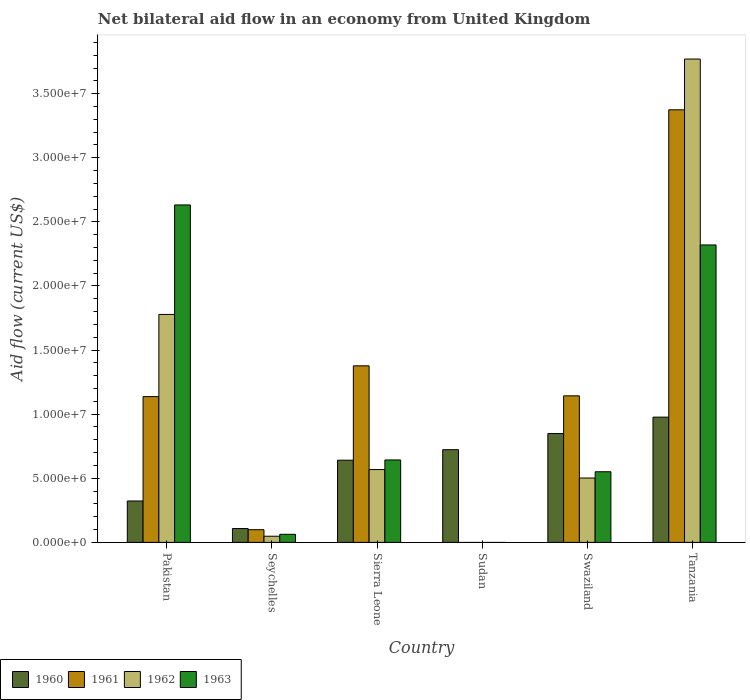How many bars are there on the 3rd tick from the left?
Make the answer very short. 4. How many bars are there on the 2nd tick from the right?
Your answer should be compact. 4. What is the label of the 2nd group of bars from the left?
Provide a succinct answer. Seychelles. Across all countries, what is the maximum net bilateral aid flow in 1962?
Your answer should be very brief. 3.77e+07. Across all countries, what is the minimum net bilateral aid flow in 1960?
Your answer should be very brief. 1.08e+06. What is the total net bilateral aid flow in 1962 in the graph?
Your response must be concise. 6.67e+07. What is the difference between the net bilateral aid flow in 1962 in Swaziland and that in Tanzania?
Ensure brevity in your answer.  -3.27e+07. What is the difference between the net bilateral aid flow in 1961 in Seychelles and the net bilateral aid flow in 1962 in Tanzania?
Give a very brief answer. -3.67e+07. What is the average net bilateral aid flow in 1960 per country?
Make the answer very short. 6.04e+06. What is the difference between the net bilateral aid flow of/in 1960 and net bilateral aid flow of/in 1961 in Tanzania?
Give a very brief answer. -2.40e+07. What is the ratio of the net bilateral aid flow in 1960 in Pakistan to that in Seychelles?
Provide a short and direct response. 2.99. Is the net bilateral aid flow in 1961 in Sierra Leone less than that in Tanzania?
Provide a succinct answer. Yes. What is the difference between the highest and the second highest net bilateral aid flow in 1963?
Make the answer very short. 3.12e+06. What is the difference between the highest and the lowest net bilateral aid flow in 1960?
Your answer should be very brief. 8.69e+06. In how many countries, is the net bilateral aid flow in 1960 greater than the average net bilateral aid flow in 1960 taken over all countries?
Your response must be concise. 4. Is the sum of the net bilateral aid flow in 1960 in Swaziland and Tanzania greater than the maximum net bilateral aid flow in 1963 across all countries?
Give a very brief answer. No. Is it the case that in every country, the sum of the net bilateral aid flow in 1962 and net bilateral aid flow in 1960 is greater than the sum of net bilateral aid flow in 1961 and net bilateral aid flow in 1963?
Offer a terse response. No. Is it the case that in every country, the sum of the net bilateral aid flow in 1961 and net bilateral aid flow in 1962 is greater than the net bilateral aid flow in 1963?
Offer a terse response. No. How many countries are there in the graph?
Your answer should be very brief. 6. What is the difference between two consecutive major ticks on the Y-axis?
Your answer should be compact. 5.00e+06. How many legend labels are there?
Your answer should be compact. 4. What is the title of the graph?
Keep it short and to the point. Net bilateral aid flow in an economy from United Kingdom. What is the Aid flow (current US$) of 1960 in Pakistan?
Your answer should be very brief. 3.23e+06. What is the Aid flow (current US$) in 1961 in Pakistan?
Make the answer very short. 1.14e+07. What is the Aid flow (current US$) of 1962 in Pakistan?
Provide a succinct answer. 1.78e+07. What is the Aid flow (current US$) of 1963 in Pakistan?
Make the answer very short. 2.63e+07. What is the Aid flow (current US$) of 1960 in Seychelles?
Provide a succinct answer. 1.08e+06. What is the Aid flow (current US$) in 1961 in Seychelles?
Give a very brief answer. 9.90e+05. What is the Aid flow (current US$) in 1963 in Seychelles?
Ensure brevity in your answer.  6.30e+05. What is the Aid flow (current US$) in 1960 in Sierra Leone?
Keep it short and to the point. 6.41e+06. What is the Aid flow (current US$) of 1961 in Sierra Leone?
Offer a terse response. 1.38e+07. What is the Aid flow (current US$) in 1962 in Sierra Leone?
Offer a very short reply. 5.68e+06. What is the Aid flow (current US$) of 1963 in Sierra Leone?
Your answer should be compact. 6.43e+06. What is the Aid flow (current US$) in 1960 in Sudan?
Your answer should be compact. 7.23e+06. What is the Aid flow (current US$) in 1961 in Sudan?
Your answer should be compact. 0. What is the Aid flow (current US$) of 1962 in Sudan?
Offer a terse response. 0. What is the Aid flow (current US$) of 1963 in Sudan?
Offer a very short reply. 0. What is the Aid flow (current US$) in 1960 in Swaziland?
Your answer should be compact. 8.49e+06. What is the Aid flow (current US$) in 1961 in Swaziland?
Your response must be concise. 1.14e+07. What is the Aid flow (current US$) of 1962 in Swaziland?
Your response must be concise. 5.02e+06. What is the Aid flow (current US$) of 1963 in Swaziland?
Ensure brevity in your answer.  5.51e+06. What is the Aid flow (current US$) of 1960 in Tanzania?
Provide a succinct answer. 9.77e+06. What is the Aid flow (current US$) of 1961 in Tanzania?
Offer a very short reply. 3.37e+07. What is the Aid flow (current US$) of 1962 in Tanzania?
Your answer should be very brief. 3.77e+07. What is the Aid flow (current US$) in 1963 in Tanzania?
Your answer should be very brief. 2.32e+07. Across all countries, what is the maximum Aid flow (current US$) of 1960?
Give a very brief answer. 9.77e+06. Across all countries, what is the maximum Aid flow (current US$) of 1961?
Provide a succinct answer. 3.37e+07. Across all countries, what is the maximum Aid flow (current US$) of 1962?
Keep it short and to the point. 3.77e+07. Across all countries, what is the maximum Aid flow (current US$) in 1963?
Offer a terse response. 2.63e+07. Across all countries, what is the minimum Aid flow (current US$) of 1960?
Keep it short and to the point. 1.08e+06. Across all countries, what is the minimum Aid flow (current US$) in 1962?
Offer a terse response. 0. What is the total Aid flow (current US$) in 1960 in the graph?
Provide a short and direct response. 3.62e+07. What is the total Aid flow (current US$) in 1961 in the graph?
Offer a terse response. 7.13e+07. What is the total Aid flow (current US$) of 1962 in the graph?
Your response must be concise. 6.67e+07. What is the total Aid flow (current US$) in 1963 in the graph?
Your answer should be compact. 6.21e+07. What is the difference between the Aid flow (current US$) of 1960 in Pakistan and that in Seychelles?
Offer a very short reply. 2.15e+06. What is the difference between the Aid flow (current US$) in 1961 in Pakistan and that in Seychelles?
Keep it short and to the point. 1.04e+07. What is the difference between the Aid flow (current US$) of 1962 in Pakistan and that in Seychelles?
Make the answer very short. 1.73e+07. What is the difference between the Aid flow (current US$) in 1963 in Pakistan and that in Seychelles?
Offer a terse response. 2.57e+07. What is the difference between the Aid flow (current US$) of 1960 in Pakistan and that in Sierra Leone?
Give a very brief answer. -3.18e+06. What is the difference between the Aid flow (current US$) of 1961 in Pakistan and that in Sierra Leone?
Provide a short and direct response. -2.40e+06. What is the difference between the Aid flow (current US$) of 1962 in Pakistan and that in Sierra Leone?
Offer a terse response. 1.21e+07. What is the difference between the Aid flow (current US$) in 1963 in Pakistan and that in Sierra Leone?
Your response must be concise. 1.99e+07. What is the difference between the Aid flow (current US$) of 1960 in Pakistan and that in Swaziland?
Your response must be concise. -5.26e+06. What is the difference between the Aid flow (current US$) in 1961 in Pakistan and that in Swaziland?
Ensure brevity in your answer.  -6.00e+04. What is the difference between the Aid flow (current US$) of 1962 in Pakistan and that in Swaziland?
Make the answer very short. 1.28e+07. What is the difference between the Aid flow (current US$) of 1963 in Pakistan and that in Swaziland?
Ensure brevity in your answer.  2.08e+07. What is the difference between the Aid flow (current US$) in 1960 in Pakistan and that in Tanzania?
Provide a succinct answer. -6.54e+06. What is the difference between the Aid flow (current US$) in 1961 in Pakistan and that in Tanzania?
Give a very brief answer. -2.24e+07. What is the difference between the Aid flow (current US$) of 1962 in Pakistan and that in Tanzania?
Give a very brief answer. -1.99e+07. What is the difference between the Aid flow (current US$) of 1963 in Pakistan and that in Tanzania?
Offer a terse response. 3.12e+06. What is the difference between the Aid flow (current US$) in 1960 in Seychelles and that in Sierra Leone?
Your response must be concise. -5.33e+06. What is the difference between the Aid flow (current US$) in 1961 in Seychelles and that in Sierra Leone?
Offer a terse response. -1.28e+07. What is the difference between the Aid flow (current US$) in 1962 in Seychelles and that in Sierra Leone?
Provide a succinct answer. -5.20e+06. What is the difference between the Aid flow (current US$) of 1963 in Seychelles and that in Sierra Leone?
Your answer should be compact. -5.80e+06. What is the difference between the Aid flow (current US$) of 1960 in Seychelles and that in Sudan?
Give a very brief answer. -6.15e+06. What is the difference between the Aid flow (current US$) in 1960 in Seychelles and that in Swaziland?
Provide a succinct answer. -7.41e+06. What is the difference between the Aid flow (current US$) of 1961 in Seychelles and that in Swaziland?
Your answer should be very brief. -1.04e+07. What is the difference between the Aid flow (current US$) in 1962 in Seychelles and that in Swaziland?
Keep it short and to the point. -4.54e+06. What is the difference between the Aid flow (current US$) in 1963 in Seychelles and that in Swaziland?
Offer a very short reply. -4.88e+06. What is the difference between the Aid flow (current US$) in 1960 in Seychelles and that in Tanzania?
Offer a terse response. -8.69e+06. What is the difference between the Aid flow (current US$) of 1961 in Seychelles and that in Tanzania?
Offer a terse response. -3.28e+07. What is the difference between the Aid flow (current US$) of 1962 in Seychelles and that in Tanzania?
Your answer should be very brief. -3.72e+07. What is the difference between the Aid flow (current US$) of 1963 in Seychelles and that in Tanzania?
Ensure brevity in your answer.  -2.26e+07. What is the difference between the Aid flow (current US$) of 1960 in Sierra Leone and that in Sudan?
Ensure brevity in your answer.  -8.20e+05. What is the difference between the Aid flow (current US$) of 1960 in Sierra Leone and that in Swaziland?
Give a very brief answer. -2.08e+06. What is the difference between the Aid flow (current US$) in 1961 in Sierra Leone and that in Swaziland?
Your answer should be very brief. 2.34e+06. What is the difference between the Aid flow (current US$) of 1962 in Sierra Leone and that in Swaziland?
Keep it short and to the point. 6.60e+05. What is the difference between the Aid flow (current US$) of 1963 in Sierra Leone and that in Swaziland?
Offer a terse response. 9.20e+05. What is the difference between the Aid flow (current US$) of 1960 in Sierra Leone and that in Tanzania?
Make the answer very short. -3.36e+06. What is the difference between the Aid flow (current US$) in 1961 in Sierra Leone and that in Tanzania?
Offer a very short reply. -2.00e+07. What is the difference between the Aid flow (current US$) of 1962 in Sierra Leone and that in Tanzania?
Give a very brief answer. -3.20e+07. What is the difference between the Aid flow (current US$) in 1963 in Sierra Leone and that in Tanzania?
Offer a very short reply. -1.68e+07. What is the difference between the Aid flow (current US$) in 1960 in Sudan and that in Swaziland?
Ensure brevity in your answer.  -1.26e+06. What is the difference between the Aid flow (current US$) in 1960 in Sudan and that in Tanzania?
Offer a very short reply. -2.54e+06. What is the difference between the Aid flow (current US$) in 1960 in Swaziland and that in Tanzania?
Your answer should be very brief. -1.28e+06. What is the difference between the Aid flow (current US$) of 1961 in Swaziland and that in Tanzania?
Ensure brevity in your answer.  -2.23e+07. What is the difference between the Aid flow (current US$) in 1962 in Swaziland and that in Tanzania?
Provide a short and direct response. -3.27e+07. What is the difference between the Aid flow (current US$) in 1963 in Swaziland and that in Tanzania?
Make the answer very short. -1.77e+07. What is the difference between the Aid flow (current US$) of 1960 in Pakistan and the Aid flow (current US$) of 1961 in Seychelles?
Your answer should be very brief. 2.24e+06. What is the difference between the Aid flow (current US$) of 1960 in Pakistan and the Aid flow (current US$) of 1962 in Seychelles?
Keep it short and to the point. 2.75e+06. What is the difference between the Aid flow (current US$) of 1960 in Pakistan and the Aid flow (current US$) of 1963 in Seychelles?
Keep it short and to the point. 2.60e+06. What is the difference between the Aid flow (current US$) in 1961 in Pakistan and the Aid flow (current US$) in 1962 in Seychelles?
Keep it short and to the point. 1.09e+07. What is the difference between the Aid flow (current US$) in 1961 in Pakistan and the Aid flow (current US$) in 1963 in Seychelles?
Provide a short and direct response. 1.07e+07. What is the difference between the Aid flow (current US$) of 1962 in Pakistan and the Aid flow (current US$) of 1963 in Seychelles?
Give a very brief answer. 1.72e+07. What is the difference between the Aid flow (current US$) of 1960 in Pakistan and the Aid flow (current US$) of 1961 in Sierra Leone?
Offer a terse response. -1.05e+07. What is the difference between the Aid flow (current US$) of 1960 in Pakistan and the Aid flow (current US$) of 1962 in Sierra Leone?
Make the answer very short. -2.45e+06. What is the difference between the Aid flow (current US$) of 1960 in Pakistan and the Aid flow (current US$) of 1963 in Sierra Leone?
Make the answer very short. -3.20e+06. What is the difference between the Aid flow (current US$) in 1961 in Pakistan and the Aid flow (current US$) in 1962 in Sierra Leone?
Give a very brief answer. 5.69e+06. What is the difference between the Aid flow (current US$) in 1961 in Pakistan and the Aid flow (current US$) in 1963 in Sierra Leone?
Keep it short and to the point. 4.94e+06. What is the difference between the Aid flow (current US$) of 1962 in Pakistan and the Aid flow (current US$) of 1963 in Sierra Leone?
Ensure brevity in your answer.  1.14e+07. What is the difference between the Aid flow (current US$) of 1960 in Pakistan and the Aid flow (current US$) of 1961 in Swaziland?
Offer a very short reply. -8.20e+06. What is the difference between the Aid flow (current US$) of 1960 in Pakistan and the Aid flow (current US$) of 1962 in Swaziland?
Your response must be concise. -1.79e+06. What is the difference between the Aid flow (current US$) of 1960 in Pakistan and the Aid flow (current US$) of 1963 in Swaziland?
Give a very brief answer. -2.28e+06. What is the difference between the Aid flow (current US$) of 1961 in Pakistan and the Aid flow (current US$) of 1962 in Swaziland?
Keep it short and to the point. 6.35e+06. What is the difference between the Aid flow (current US$) of 1961 in Pakistan and the Aid flow (current US$) of 1963 in Swaziland?
Your answer should be very brief. 5.86e+06. What is the difference between the Aid flow (current US$) of 1962 in Pakistan and the Aid flow (current US$) of 1963 in Swaziland?
Make the answer very short. 1.23e+07. What is the difference between the Aid flow (current US$) in 1960 in Pakistan and the Aid flow (current US$) in 1961 in Tanzania?
Provide a succinct answer. -3.05e+07. What is the difference between the Aid flow (current US$) of 1960 in Pakistan and the Aid flow (current US$) of 1962 in Tanzania?
Give a very brief answer. -3.45e+07. What is the difference between the Aid flow (current US$) of 1960 in Pakistan and the Aid flow (current US$) of 1963 in Tanzania?
Ensure brevity in your answer.  -2.00e+07. What is the difference between the Aid flow (current US$) in 1961 in Pakistan and the Aid flow (current US$) in 1962 in Tanzania?
Offer a very short reply. -2.63e+07. What is the difference between the Aid flow (current US$) of 1961 in Pakistan and the Aid flow (current US$) of 1963 in Tanzania?
Your answer should be very brief. -1.18e+07. What is the difference between the Aid flow (current US$) in 1962 in Pakistan and the Aid flow (current US$) in 1963 in Tanzania?
Provide a succinct answer. -5.42e+06. What is the difference between the Aid flow (current US$) in 1960 in Seychelles and the Aid flow (current US$) in 1961 in Sierra Leone?
Your answer should be very brief. -1.27e+07. What is the difference between the Aid flow (current US$) of 1960 in Seychelles and the Aid flow (current US$) of 1962 in Sierra Leone?
Your answer should be compact. -4.60e+06. What is the difference between the Aid flow (current US$) in 1960 in Seychelles and the Aid flow (current US$) in 1963 in Sierra Leone?
Give a very brief answer. -5.35e+06. What is the difference between the Aid flow (current US$) in 1961 in Seychelles and the Aid flow (current US$) in 1962 in Sierra Leone?
Ensure brevity in your answer.  -4.69e+06. What is the difference between the Aid flow (current US$) in 1961 in Seychelles and the Aid flow (current US$) in 1963 in Sierra Leone?
Provide a succinct answer. -5.44e+06. What is the difference between the Aid flow (current US$) in 1962 in Seychelles and the Aid flow (current US$) in 1963 in Sierra Leone?
Your answer should be very brief. -5.95e+06. What is the difference between the Aid flow (current US$) of 1960 in Seychelles and the Aid flow (current US$) of 1961 in Swaziland?
Offer a very short reply. -1.04e+07. What is the difference between the Aid flow (current US$) in 1960 in Seychelles and the Aid flow (current US$) in 1962 in Swaziland?
Your answer should be compact. -3.94e+06. What is the difference between the Aid flow (current US$) in 1960 in Seychelles and the Aid flow (current US$) in 1963 in Swaziland?
Your answer should be very brief. -4.43e+06. What is the difference between the Aid flow (current US$) of 1961 in Seychelles and the Aid flow (current US$) of 1962 in Swaziland?
Your answer should be compact. -4.03e+06. What is the difference between the Aid flow (current US$) in 1961 in Seychelles and the Aid flow (current US$) in 1963 in Swaziland?
Offer a terse response. -4.52e+06. What is the difference between the Aid flow (current US$) of 1962 in Seychelles and the Aid flow (current US$) of 1963 in Swaziland?
Ensure brevity in your answer.  -5.03e+06. What is the difference between the Aid flow (current US$) of 1960 in Seychelles and the Aid flow (current US$) of 1961 in Tanzania?
Your answer should be very brief. -3.27e+07. What is the difference between the Aid flow (current US$) of 1960 in Seychelles and the Aid flow (current US$) of 1962 in Tanzania?
Make the answer very short. -3.66e+07. What is the difference between the Aid flow (current US$) in 1960 in Seychelles and the Aid flow (current US$) in 1963 in Tanzania?
Your answer should be very brief. -2.21e+07. What is the difference between the Aid flow (current US$) of 1961 in Seychelles and the Aid flow (current US$) of 1962 in Tanzania?
Provide a succinct answer. -3.67e+07. What is the difference between the Aid flow (current US$) of 1961 in Seychelles and the Aid flow (current US$) of 1963 in Tanzania?
Keep it short and to the point. -2.22e+07. What is the difference between the Aid flow (current US$) of 1962 in Seychelles and the Aid flow (current US$) of 1963 in Tanzania?
Your answer should be very brief. -2.27e+07. What is the difference between the Aid flow (current US$) of 1960 in Sierra Leone and the Aid flow (current US$) of 1961 in Swaziland?
Offer a terse response. -5.02e+06. What is the difference between the Aid flow (current US$) of 1960 in Sierra Leone and the Aid flow (current US$) of 1962 in Swaziland?
Your answer should be very brief. 1.39e+06. What is the difference between the Aid flow (current US$) in 1961 in Sierra Leone and the Aid flow (current US$) in 1962 in Swaziland?
Your answer should be compact. 8.75e+06. What is the difference between the Aid flow (current US$) in 1961 in Sierra Leone and the Aid flow (current US$) in 1963 in Swaziland?
Keep it short and to the point. 8.26e+06. What is the difference between the Aid flow (current US$) of 1960 in Sierra Leone and the Aid flow (current US$) of 1961 in Tanzania?
Provide a short and direct response. -2.73e+07. What is the difference between the Aid flow (current US$) of 1960 in Sierra Leone and the Aid flow (current US$) of 1962 in Tanzania?
Provide a short and direct response. -3.13e+07. What is the difference between the Aid flow (current US$) in 1960 in Sierra Leone and the Aid flow (current US$) in 1963 in Tanzania?
Your answer should be compact. -1.68e+07. What is the difference between the Aid flow (current US$) in 1961 in Sierra Leone and the Aid flow (current US$) in 1962 in Tanzania?
Ensure brevity in your answer.  -2.39e+07. What is the difference between the Aid flow (current US$) of 1961 in Sierra Leone and the Aid flow (current US$) of 1963 in Tanzania?
Offer a terse response. -9.43e+06. What is the difference between the Aid flow (current US$) of 1962 in Sierra Leone and the Aid flow (current US$) of 1963 in Tanzania?
Your response must be concise. -1.75e+07. What is the difference between the Aid flow (current US$) in 1960 in Sudan and the Aid flow (current US$) in 1961 in Swaziland?
Provide a succinct answer. -4.20e+06. What is the difference between the Aid flow (current US$) in 1960 in Sudan and the Aid flow (current US$) in 1962 in Swaziland?
Ensure brevity in your answer.  2.21e+06. What is the difference between the Aid flow (current US$) in 1960 in Sudan and the Aid flow (current US$) in 1963 in Swaziland?
Make the answer very short. 1.72e+06. What is the difference between the Aid flow (current US$) of 1960 in Sudan and the Aid flow (current US$) of 1961 in Tanzania?
Provide a short and direct response. -2.65e+07. What is the difference between the Aid flow (current US$) of 1960 in Sudan and the Aid flow (current US$) of 1962 in Tanzania?
Provide a succinct answer. -3.05e+07. What is the difference between the Aid flow (current US$) of 1960 in Sudan and the Aid flow (current US$) of 1963 in Tanzania?
Your response must be concise. -1.60e+07. What is the difference between the Aid flow (current US$) in 1960 in Swaziland and the Aid flow (current US$) in 1961 in Tanzania?
Keep it short and to the point. -2.52e+07. What is the difference between the Aid flow (current US$) of 1960 in Swaziland and the Aid flow (current US$) of 1962 in Tanzania?
Keep it short and to the point. -2.92e+07. What is the difference between the Aid flow (current US$) in 1960 in Swaziland and the Aid flow (current US$) in 1963 in Tanzania?
Give a very brief answer. -1.47e+07. What is the difference between the Aid flow (current US$) of 1961 in Swaziland and the Aid flow (current US$) of 1962 in Tanzania?
Keep it short and to the point. -2.63e+07. What is the difference between the Aid flow (current US$) of 1961 in Swaziland and the Aid flow (current US$) of 1963 in Tanzania?
Your answer should be very brief. -1.18e+07. What is the difference between the Aid flow (current US$) in 1962 in Swaziland and the Aid flow (current US$) in 1963 in Tanzania?
Ensure brevity in your answer.  -1.82e+07. What is the average Aid flow (current US$) of 1960 per country?
Your response must be concise. 6.04e+06. What is the average Aid flow (current US$) in 1961 per country?
Give a very brief answer. 1.19e+07. What is the average Aid flow (current US$) in 1962 per country?
Your response must be concise. 1.11e+07. What is the average Aid flow (current US$) in 1963 per country?
Provide a short and direct response. 1.03e+07. What is the difference between the Aid flow (current US$) in 1960 and Aid flow (current US$) in 1961 in Pakistan?
Ensure brevity in your answer.  -8.14e+06. What is the difference between the Aid flow (current US$) of 1960 and Aid flow (current US$) of 1962 in Pakistan?
Provide a succinct answer. -1.46e+07. What is the difference between the Aid flow (current US$) of 1960 and Aid flow (current US$) of 1963 in Pakistan?
Keep it short and to the point. -2.31e+07. What is the difference between the Aid flow (current US$) in 1961 and Aid flow (current US$) in 1962 in Pakistan?
Give a very brief answer. -6.41e+06. What is the difference between the Aid flow (current US$) of 1961 and Aid flow (current US$) of 1963 in Pakistan?
Keep it short and to the point. -1.50e+07. What is the difference between the Aid flow (current US$) in 1962 and Aid flow (current US$) in 1963 in Pakistan?
Keep it short and to the point. -8.54e+06. What is the difference between the Aid flow (current US$) in 1960 and Aid flow (current US$) in 1961 in Seychelles?
Your response must be concise. 9.00e+04. What is the difference between the Aid flow (current US$) of 1961 and Aid flow (current US$) of 1962 in Seychelles?
Offer a very short reply. 5.10e+05. What is the difference between the Aid flow (current US$) of 1960 and Aid flow (current US$) of 1961 in Sierra Leone?
Provide a succinct answer. -7.36e+06. What is the difference between the Aid flow (current US$) of 1960 and Aid flow (current US$) of 1962 in Sierra Leone?
Provide a succinct answer. 7.30e+05. What is the difference between the Aid flow (current US$) of 1960 and Aid flow (current US$) of 1963 in Sierra Leone?
Make the answer very short. -2.00e+04. What is the difference between the Aid flow (current US$) of 1961 and Aid flow (current US$) of 1962 in Sierra Leone?
Give a very brief answer. 8.09e+06. What is the difference between the Aid flow (current US$) of 1961 and Aid flow (current US$) of 1963 in Sierra Leone?
Your response must be concise. 7.34e+06. What is the difference between the Aid flow (current US$) of 1962 and Aid flow (current US$) of 1963 in Sierra Leone?
Your response must be concise. -7.50e+05. What is the difference between the Aid flow (current US$) in 1960 and Aid flow (current US$) in 1961 in Swaziland?
Give a very brief answer. -2.94e+06. What is the difference between the Aid flow (current US$) of 1960 and Aid flow (current US$) of 1962 in Swaziland?
Offer a very short reply. 3.47e+06. What is the difference between the Aid flow (current US$) of 1960 and Aid flow (current US$) of 1963 in Swaziland?
Your response must be concise. 2.98e+06. What is the difference between the Aid flow (current US$) in 1961 and Aid flow (current US$) in 1962 in Swaziland?
Make the answer very short. 6.41e+06. What is the difference between the Aid flow (current US$) of 1961 and Aid flow (current US$) of 1963 in Swaziland?
Provide a succinct answer. 5.92e+06. What is the difference between the Aid flow (current US$) in 1962 and Aid flow (current US$) in 1963 in Swaziland?
Give a very brief answer. -4.90e+05. What is the difference between the Aid flow (current US$) of 1960 and Aid flow (current US$) of 1961 in Tanzania?
Provide a succinct answer. -2.40e+07. What is the difference between the Aid flow (current US$) of 1960 and Aid flow (current US$) of 1962 in Tanzania?
Your answer should be compact. -2.79e+07. What is the difference between the Aid flow (current US$) of 1960 and Aid flow (current US$) of 1963 in Tanzania?
Your response must be concise. -1.34e+07. What is the difference between the Aid flow (current US$) of 1961 and Aid flow (current US$) of 1962 in Tanzania?
Your response must be concise. -3.96e+06. What is the difference between the Aid flow (current US$) in 1961 and Aid flow (current US$) in 1963 in Tanzania?
Keep it short and to the point. 1.05e+07. What is the difference between the Aid flow (current US$) of 1962 and Aid flow (current US$) of 1963 in Tanzania?
Your answer should be very brief. 1.45e+07. What is the ratio of the Aid flow (current US$) of 1960 in Pakistan to that in Seychelles?
Make the answer very short. 2.99. What is the ratio of the Aid flow (current US$) of 1961 in Pakistan to that in Seychelles?
Make the answer very short. 11.48. What is the ratio of the Aid flow (current US$) in 1962 in Pakistan to that in Seychelles?
Ensure brevity in your answer.  37.04. What is the ratio of the Aid flow (current US$) of 1963 in Pakistan to that in Seychelles?
Your response must be concise. 41.78. What is the ratio of the Aid flow (current US$) in 1960 in Pakistan to that in Sierra Leone?
Your response must be concise. 0.5. What is the ratio of the Aid flow (current US$) in 1961 in Pakistan to that in Sierra Leone?
Your answer should be very brief. 0.83. What is the ratio of the Aid flow (current US$) in 1962 in Pakistan to that in Sierra Leone?
Your response must be concise. 3.13. What is the ratio of the Aid flow (current US$) of 1963 in Pakistan to that in Sierra Leone?
Ensure brevity in your answer.  4.09. What is the ratio of the Aid flow (current US$) in 1960 in Pakistan to that in Sudan?
Provide a short and direct response. 0.45. What is the ratio of the Aid flow (current US$) of 1960 in Pakistan to that in Swaziland?
Provide a short and direct response. 0.38. What is the ratio of the Aid flow (current US$) of 1962 in Pakistan to that in Swaziland?
Your answer should be compact. 3.54. What is the ratio of the Aid flow (current US$) in 1963 in Pakistan to that in Swaziland?
Ensure brevity in your answer.  4.78. What is the ratio of the Aid flow (current US$) of 1960 in Pakistan to that in Tanzania?
Provide a short and direct response. 0.33. What is the ratio of the Aid flow (current US$) of 1961 in Pakistan to that in Tanzania?
Offer a terse response. 0.34. What is the ratio of the Aid flow (current US$) of 1962 in Pakistan to that in Tanzania?
Make the answer very short. 0.47. What is the ratio of the Aid flow (current US$) in 1963 in Pakistan to that in Tanzania?
Your answer should be very brief. 1.13. What is the ratio of the Aid flow (current US$) in 1960 in Seychelles to that in Sierra Leone?
Keep it short and to the point. 0.17. What is the ratio of the Aid flow (current US$) of 1961 in Seychelles to that in Sierra Leone?
Your answer should be compact. 0.07. What is the ratio of the Aid flow (current US$) in 1962 in Seychelles to that in Sierra Leone?
Make the answer very short. 0.08. What is the ratio of the Aid flow (current US$) of 1963 in Seychelles to that in Sierra Leone?
Ensure brevity in your answer.  0.1. What is the ratio of the Aid flow (current US$) of 1960 in Seychelles to that in Sudan?
Make the answer very short. 0.15. What is the ratio of the Aid flow (current US$) in 1960 in Seychelles to that in Swaziland?
Keep it short and to the point. 0.13. What is the ratio of the Aid flow (current US$) in 1961 in Seychelles to that in Swaziland?
Your answer should be compact. 0.09. What is the ratio of the Aid flow (current US$) in 1962 in Seychelles to that in Swaziland?
Ensure brevity in your answer.  0.1. What is the ratio of the Aid flow (current US$) in 1963 in Seychelles to that in Swaziland?
Offer a very short reply. 0.11. What is the ratio of the Aid flow (current US$) of 1960 in Seychelles to that in Tanzania?
Provide a succinct answer. 0.11. What is the ratio of the Aid flow (current US$) of 1961 in Seychelles to that in Tanzania?
Provide a succinct answer. 0.03. What is the ratio of the Aid flow (current US$) of 1962 in Seychelles to that in Tanzania?
Offer a terse response. 0.01. What is the ratio of the Aid flow (current US$) of 1963 in Seychelles to that in Tanzania?
Give a very brief answer. 0.03. What is the ratio of the Aid flow (current US$) of 1960 in Sierra Leone to that in Sudan?
Keep it short and to the point. 0.89. What is the ratio of the Aid flow (current US$) of 1960 in Sierra Leone to that in Swaziland?
Ensure brevity in your answer.  0.76. What is the ratio of the Aid flow (current US$) of 1961 in Sierra Leone to that in Swaziland?
Offer a terse response. 1.2. What is the ratio of the Aid flow (current US$) in 1962 in Sierra Leone to that in Swaziland?
Offer a terse response. 1.13. What is the ratio of the Aid flow (current US$) of 1963 in Sierra Leone to that in Swaziland?
Provide a short and direct response. 1.17. What is the ratio of the Aid flow (current US$) in 1960 in Sierra Leone to that in Tanzania?
Offer a terse response. 0.66. What is the ratio of the Aid flow (current US$) of 1961 in Sierra Leone to that in Tanzania?
Your answer should be very brief. 0.41. What is the ratio of the Aid flow (current US$) of 1962 in Sierra Leone to that in Tanzania?
Your response must be concise. 0.15. What is the ratio of the Aid flow (current US$) in 1963 in Sierra Leone to that in Tanzania?
Your answer should be very brief. 0.28. What is the ratio of the Aid flow (current US$) of 1960 in Sudan to that in Swaziland?
Keep it short and to the point. 0.85. What is the ratio of the Aid flow (current US$) in 1960 in Sudan to that in Tanzania?
Your answer should be very brief. 0.74. What is the ratio of the Aid flow (current US$) of 1960 in Swaziland to that in Tanzania?
Make the answer very short. 0.87. What is the ratio of the Aid flow (current US$) in 1961 in Swaziland to that in Tanzania?
Give a very brief answer. 0.34. What is the ratio of the Aid flow (current US$) of 1962 in Swaziland to that in Tanzania?
Provide a short and direct response. 0.13. What is the ratio of the Aid flow (current US$) of 1963 in Swaziland to that in Tanzania?
Provide a short and direct response. 0.24. What is the difference between the highest and the second highest Aid flow (current US$) in 1960?
Your answer should be compact. 1.28e+06. What is the difference between the highest and the second highest Aid flow (current US$) in 1961?
Your response must be concise. 2.00e+07. What is the difference between the highest and the second highest Aid flow (current US$) in 1962?
Keep it short and to the point. 1.99e+07. What is the difference between the highest and the second highest Aid flow (current US$) of 1963?
Provide a short and direct response. 3.12e+06. What is the difference between the highest and the lowest Aid flow (current US$) in 1960?
Offer a very short reply. 8.69e+06. What is the difference between the highest and the lowest Aid flow (current US$) of 1961?
Your answer should be very brief. 3.37e+07. What is the difference between the highest and the lowest Aid flow (current US$) in 1962?
Offer a very short reply. 3.77e+07. What is the difference between the highest and the lowest Aid flow (current US$) of 1963?
Provide a succinct answer. 2.63e+07. 